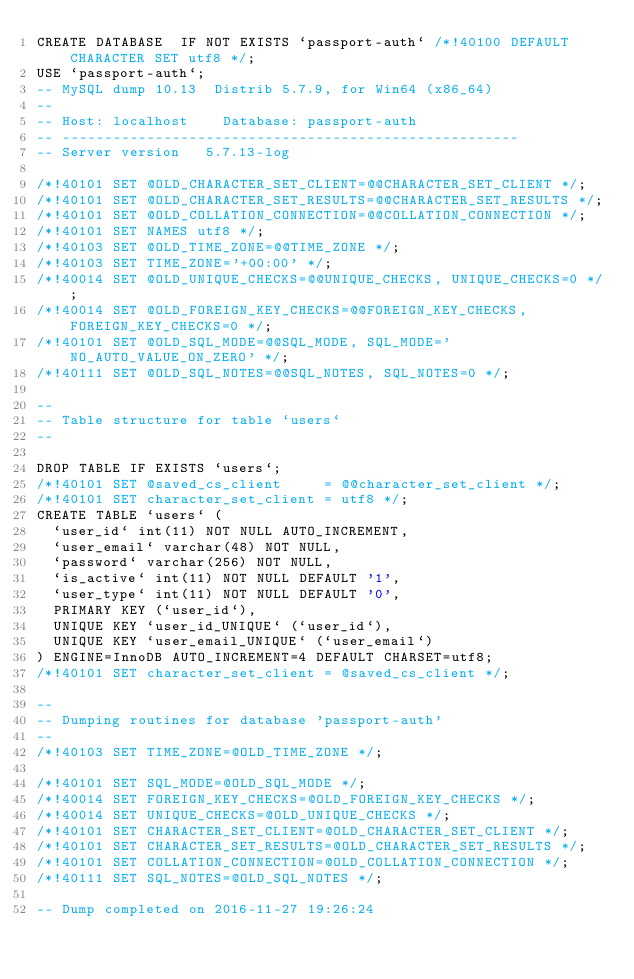Convert code to text. <code><loc_0><loc_0><loc_500><loc_500><_SQL_>CREATE DATABASE  IF NOT EXISTS `passport-auth` /*!40100 DEFAULT CHARACTER SET utf8 */;
USE `passport-auth`;
-- MySQL dump 10.13  Distrib 5.7.9, for Win64 (x86_64)
--
-- Host: localhost    Database: passport-auth
-- ------------------------------------------------------
-- Server version	5.7.13-log

/*!40101 SET @OLD_CHARACTER_SET_CLIENT=@@CHARACTER_SET_CLIENT */;
/*!40101 SET @OLD_CHARACTER_SET_RESULTS=@@CHARACTER_SET_RESULTS */;
/*!40101 SET @OLD_COLLATION_CONNECTION=@@COLLATION_CONNECTION */;
/*!40101 SET NAMES utf8 */;
/*!40103 SET @OLD_TIME_ZONE=@@TIME_ZONE */;
/*!40103 SET TIME_ZONE='+00:00' */;
/*!40014 SET @OLD_UNIQUE_CHECKS=@@UNIQUE_CHECKS, UNIQUE_CHECKS=0 */;
/*!40014 SET @OLD_FOREIGN_KEY_CHECKS=@@FOREIGN_KEY_CHECKS, FOREIGN_KEY_CHECKS=0 */;
/*!40101 SET @OLD_SQL_MODE=@@SQL_MODE, SQL_MODE='NO_AUTO_VALUE_ON_ZERO' */;
/*!40111 SET @OLD_SQL_NOTES=@@SQL_NOTES, SQL_NOTES=0 */;

--
-- Table structure for table `users`
--

DROP TABLE IF EXISTS `users`;
/*!40101 SET @saved_cs_client     = @@character_set_client */;
/*!40101 SET character_set_client = utf8 */;
CREATE TABLE `users` (
  `user_id` int(11) NOT NULL AUTO_INCREMENT,
  `user_email` varchar(48) NOT NULL,
  `password` varchar(256) NOT NULL,
  `is_active` int(11) NOT NULL DEFAULT '1',
  `user_type` int(11) NOT NULL DEFAULT '0',
  PRIMARY KEY (`user_id`),
  UNIQUE KEY `user_id_UNIQUE` (`user_id`),
  UNIQUE KEY `user_email_UNIQUE` (`user_email`)
) ENGINE=InnoDB AUTO_INCREMENT=4 DEFAULT CHARSET=utf8;
/*!40101 SET character_set_client = @saved_cs_client */;

--
-- Dumping routines for database 'passport-auth'
--
/*!40103 SET TIME_ZONE=@OLD_TIME_ZONE */;

/*!40101 SET SQL_MODE=@OLD_SQL_MODE */;
/*!40014 SET FOREIGN_KEY_CHECKS=@OLD_FOREIGN_KEY_CHECKS */;
/*!40014 SET UNIQUE_CHECKS=@OLD_UNIQUE_CHECKS */;
/*!40101 SET CHARACTER_SET_CLIENT=@OLD_CHARACTER_SET_CLIENT */;
/*!40101 SET CHARACTER_SET_RESULTS=@OLD_CHARACTER_SET_RESULTS */;
/*!40101 SET COLLATION_CONNECTION=@OLD_COLLATION_CONNECTION */;
/*!40111 SET SQL_NOTES=@OLD_SQL_NOTES */;

-- Dump completed on 2016-11-27 19:26:24
</code> 